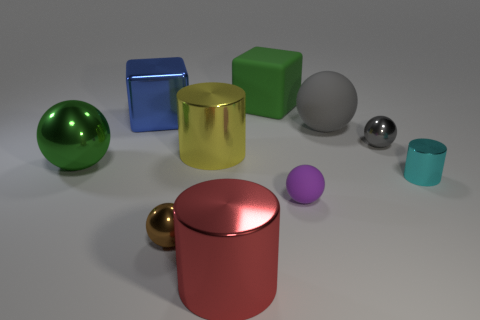There is a rubber ball that is in front of the green ball; what is its color?
Ensure brevity in your answer.  Purple. Is the blue cube made of the same material as the big green object that is in front of the big green matte block?
Ensure brevity in your answer.  Yes. What is the blue cube made of?
Offer a very short reply. Metal. The small cyan object that is made of the same material as the large yellow thing is what shape?
Ensure brevity in your answer.  Cylinder. How many other objects are the same shape as the tiny purple rubber thing?
Provide a succinct answer. 4. There is a big green matte cube; how many objects are to the left of it?
Make the answer very short. 5. Is the size of the red metal cylinder that is in front of the purple object the same as the ball that is left of the brown metal sphere?
Make the answer very short. Yes. How many other objects are the same size as the green sphere?
Make the answer very short. 5. There is a gray ball that is right of the big ball that is right of the large blue metal block behind the green metallic sphere; what is its material?
Provide a short and direct response. Metal. Is the number of small cyan metal cylinders the same as the number of large metal cylinders?
Provide a short and direct response. No. 